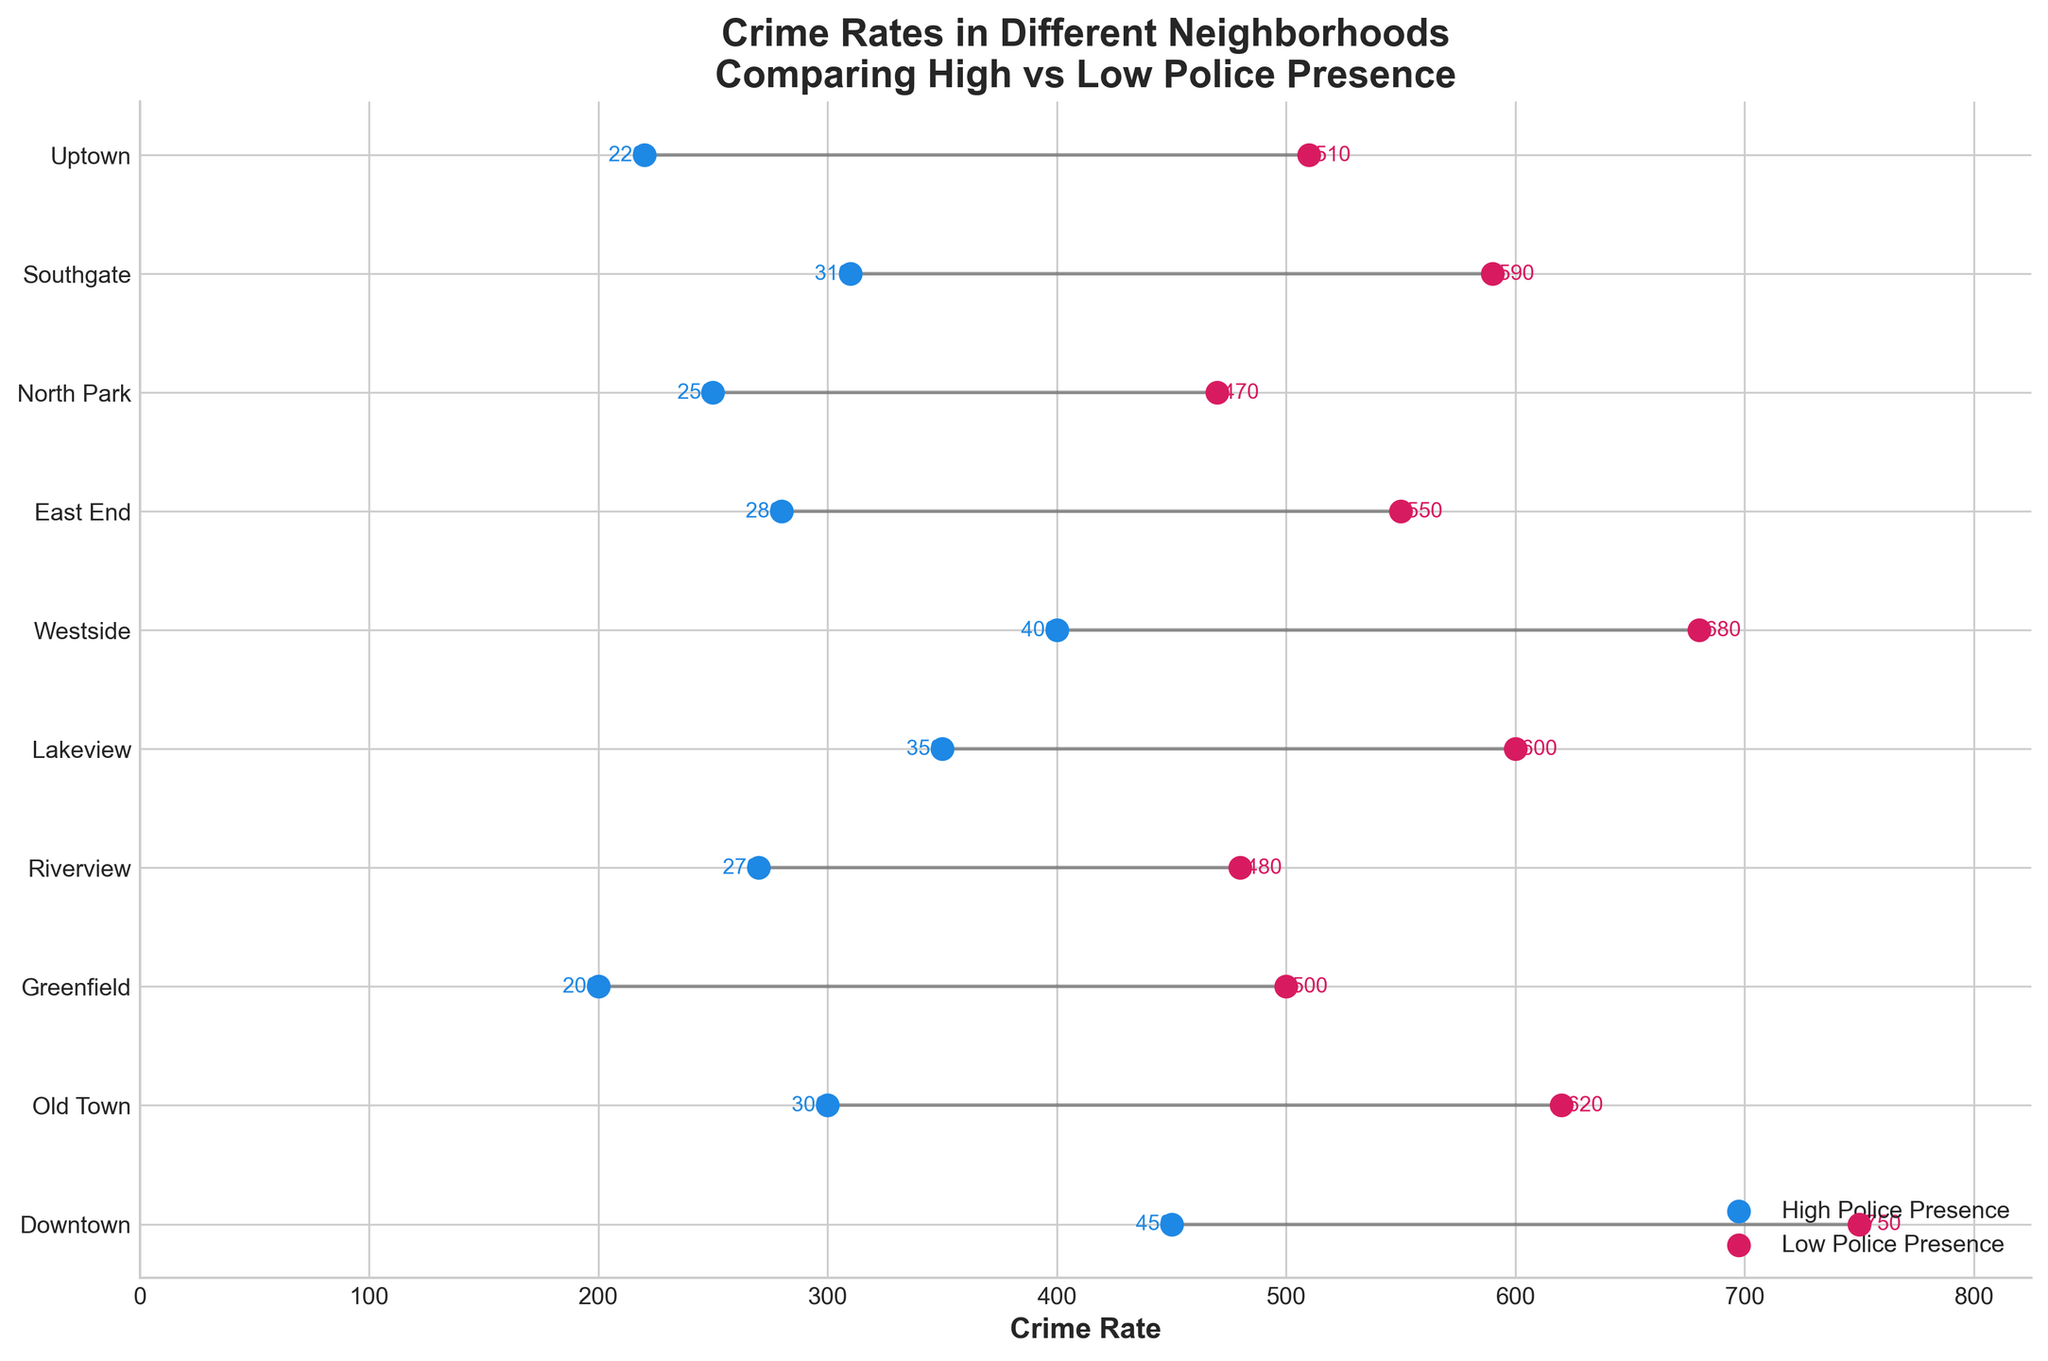What's the title of the figure? Look at the text at the top center of the figure which describes the plot.
Answer: Crime Rates in Different Neighborhoods Comparing High vs Low Police Presence What is the crime rate in Downtown with high police presence? Find the blue dot corresponding to Downtown on the y-axis, then read the crime rate on the x-axis.
Answer: 450 Which neighborhood has the largest difference in crime rates between high and low police presence? Calculate the difference for each neighborhood by subtracting the high police presence rate from the low police presence rate, and find the maximum difference. Downtown: 750-450=300, Old Town: 620-300=320, Greenfield: 500-200=300, Riverview: 480-270=210, Lakeview: 600-350=250, Westside: 680-400=280, East End: 550-280=270, North Park: 470-250=220, Southgate: 590-310=280, Uptown: 510-220=290. The largest difference is in Old Town with a difference of 320.
Answer: Old Town In which neighborhood does the crime rate remain under 300 with both high and low police presence? Find the neighborhoods where both blue and red dots are positioned under 300 on the x-axis. The neighborhoods that satisfy this condition are Uptown for high police presence with a crime rate of 220 and Greenfield with crime rates below 300 for both high (200) and low (500) police presence.
Answer: Uptown Which neighborhoods have a crime rate lower than 250 under high police presence? Identify the blue dots on the x-axis that are below the 250 mark. The neighborhoods that satisfy this condition are Greenfield, North Park, and Uptown.
Answer: Greenfield, North Park, Uptown Which neighborhood has the highest crime rate under low police presence? Locate the highest red dot on the x-axis and read its corresponding neighborhood. The neighborhood with the highest rate is Downtown with a crime rate of 750.
Answer: Downtown What is the average crime rate of all neighborhoods under high police presence? Add all the high police presence crime rates together then divide by the number of neighborhoods. Total = 450 + 300 + 200 + 270 + 350 + 400 + 280 + 250 + 310 + 220 = 3030. Average = 3030 / 10 = 303
Answer: 303 What is the crime rate difference between Uptown and East End under low police presence? Subtract the crime rate of Uptown under low police presence from that of East End. 550 (East End) - 510 (Uptown) = 40
Answer: 40 Which neighborhood shows the smallest difference in crime rates between high and low police presence? Calculate the difference for each neighborhood and identify the smallest value. Downtown: 750-450=300, Old Town: 620-300=320, Greenfield: 500-200=300, Riverview: 480-270=210, Lakeview: 600-350=250, Westside: 680-400=280, East End: 550-280=270, North Park: 470-250=220, Southgate: 590-310=280, Uptown: 510-220=290. The smallest difference is in Riverview with a difference of 210.
Answer: Riverview 